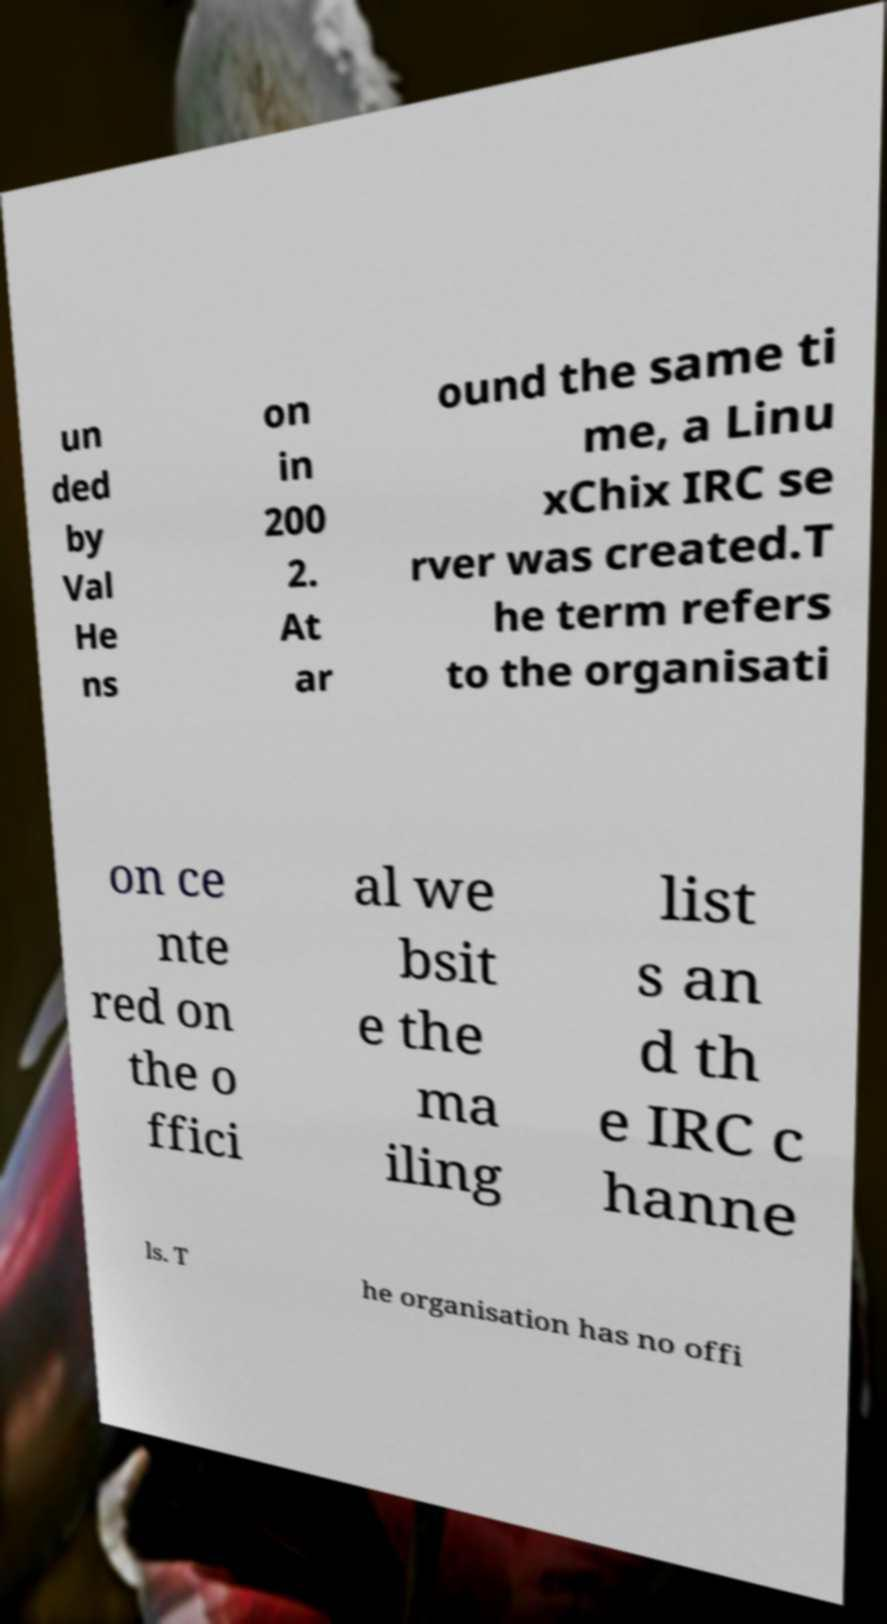Can you accurately transcribe the text from the provided image for me? un ded by Val He ns on in 200 2. At ar ound the same ti me, a Linu xChix IRC se rver was created.T he term refers to the organisati on ce nte red on the o ffici al we bsit e the ma iling list s an d th e IRC c hanne ls. T he organisation has no offi 